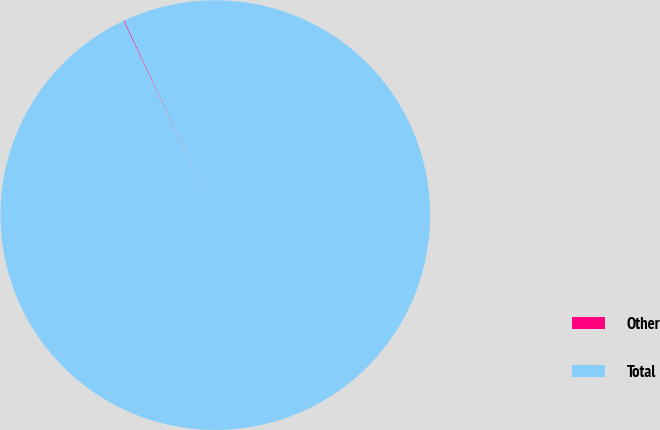Convert chart. <chart><loc_0><loc_0><loc_500><loc_500><pie_chart><fcel>Other<fcel>Total<nl><fcel>0.07%<fcel>99.93%<nl></chart> 